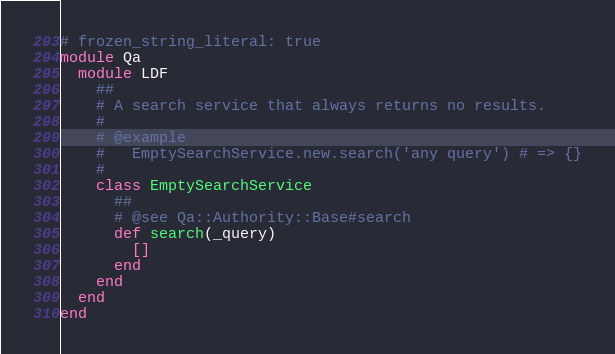Convert code to text. <code><loc_0><loc_0><loc_500><loc_500><_Ruby_># frozen_string_literal: true
module Qa
  module LDF
    ##
    # A search service that always returns no results.
    #
    # @example
    #   EmptySearchService.new.search('any query') # => {}
    #
    class EmptySearchService
      ##
      # @see Qa::Authority::Base#search
      def search(_query)
        []
      end
    end
  end
end
</code> 